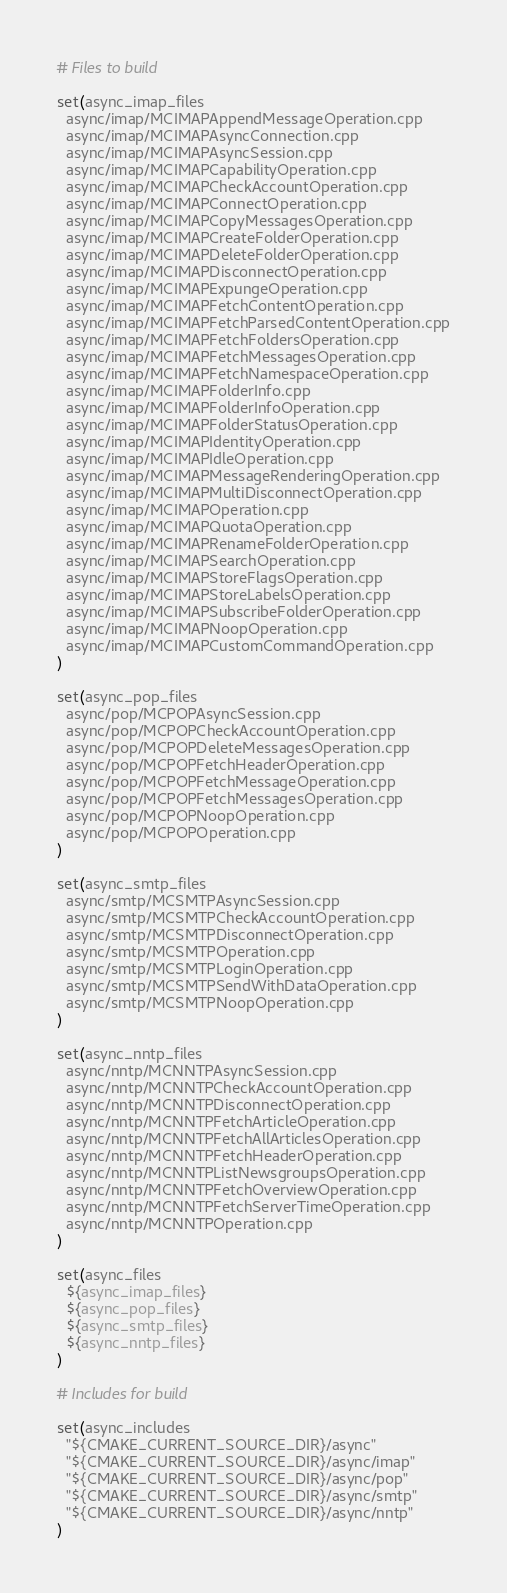Convert code to text. <code><loc_0><loc_0><loc_500><loc_500><_CMake_># Files to build

set(async_imap_files
  async/imap/MCIMAPAppendMessageOperation.cpp
  async/imap/MCIMAPAsyncConnection.cpp
  async/imap/MCIMAPAsyncSession.cpp
  async/imap/MCIMAPCapabilityOperation.cpp
  async/imap/MCIMAPCheckAccountOperation.cpp
  async/imap/MCIMAPConnectOperation.cpp
  async/imap/MCIMAPCopyMessagesOperation.cpp
  async/imap/MCIMAPCreateFolderOperation.cpp
  async/imap/MCIMAPDeleteFolderOperation.cpp
  async/imap/MCIMAPDisconnectOperation.cpp
  async/imap/MCIMAPExpungeOperation.cpp
  async/imap/MCIMAPFetchContentOperation.cpp
  async/imap/MCIMAPFetchParsedContentOperation.cpp
  async/imap/MCIMAPFetchFoldersOperation.cpp
  async/imap/MCIMAPFetchMessagesOperation.cpp
  async/imap/MCIMAPFetchNamespaceOperation.cpp
  async/imap/MCIMAPFolderInfo.cpp
  async/imap/MCIMAPFolderInfoOperation.cpp
  async/imap/MCIMAPFolderStatusOperation.cpp
  async/imap/MCIMAPIdentityOperation.cpp
  async/imap/MCIMAPIdleOperation.cpp
  async/imap/MCIMAPMessageRenderingOperation.cpp
  async/imap/MCIMAPMultiDisconnectOperation.cpp
  async/imap/MCIMAPOperation.cpp
  async/imap/MCIMAPQuotaOperation.cpp
  async/imap/MCIMAPRenameFolderOperation.cpp
  async/imap/MCIMAPSearchOperation.cpp
  async/imap/MCIMAPStoreFlagsOperation.cpp
  async/imap/MCIMAPStoreLabelsOperation.cpp
  async/imap/MCIMAPSubscribeFolderOperation.cpp
  async/imap/MCIMAPNoopOperation.cpp
  async/imap/MCIMAPCustomCommandOperation.cpp
)

set(async_pop_files
  async/pop/MCPOPAsyncSession.cpp
  async/pop/MCPOPCheckAccountOperation.cpp
  async/pop/MCPOPDeleteMessagesOperation.cpp
  async/pop/MCPOPFetchHeaderOperation.cpp
  async/pop/MCPOPFetchMessageOperation.cpp
  async/pop/MCPOPFetchMessagesOperation.cpp
  async/pop/MCPOPNoopOperation.cpp
  async/pop/MCPOPOperation.cpp
)

set(async_smtp_files
  async/smtp/MCSMTPAsyncSession.cpp
  async/smtp/MCSMTPCheckAccountOperation.cpp
  async/smtp/MCSMTPDisconnectOperation.cpp
  async/smtp/MCSMTPOperation.cpp
  async/smtp/MCSMTPLoginOperation.cpp
  async/smtp/MCSMTPSendWithDataOperation.cpp
  async/smtp/MCSMTPNoopOperation.cpp
)

set(async_nntp_files
  async/nntp/MCNNTPAsyncSession.cpp
  async/nntp/MCNNTPCheckAccountOperation.cpp
  async/nntp/MCNNTPDisconnectOperation.cpp
  async/nntp/MCNNTPFetchArticleOperation.cpp
  async/nntp/MCNNTPFetchAllArticlesOperation.cpp
  async/nntp/MCNNTPFetchHeaderOperation.cpp
  async/nntp/MCNNTPListNewsgroupsOperation.cpp
  async/nntp/MCNNTPFetchOverviewOperation.cpp
  async/nntp/MCNNTPFetchServerTimeOperation.cpp
  async/nntp/MCNNTPOperation.cpp
)

set(async_files
  ${async_imap_files}
  ${async_pop_files}
  ${async_smtp_files}
  ${async_nntp_files}
)

# Includes for build

set(async_includes
  "${CMAKE_CURRENT_SOURCE_DIR}/async"
  "${CMAKE_CURRENT_SOURCE_DIR}/async/imap"
  "${CMAKE_CURRENT_SOURCE_DIR}/async/pop"
  "${CMAKE_CURRENT_SOURCE_DIR}/async/smtp"
  "${CMAKE_CURRENT_SOURCE_DIR}/async/nntp"
)
</code> 